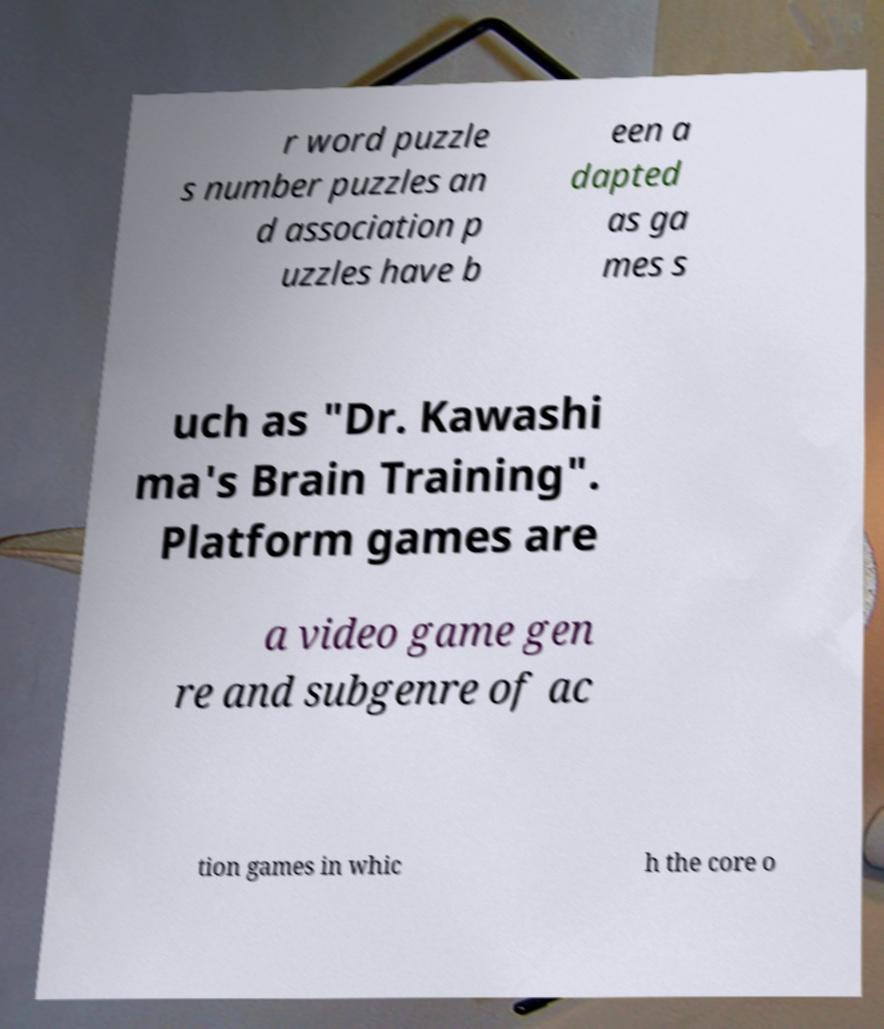Could you assist in decoding the text presented in this image and type it out clearly? r word puzzle s number puzzles an d association p uzzles have b een a dapted as ga mes s uch as "Dr. Kawashi ma's Brain Training". Platform games are a video game gen re and subgenre of ac tion games in whic h the core o 